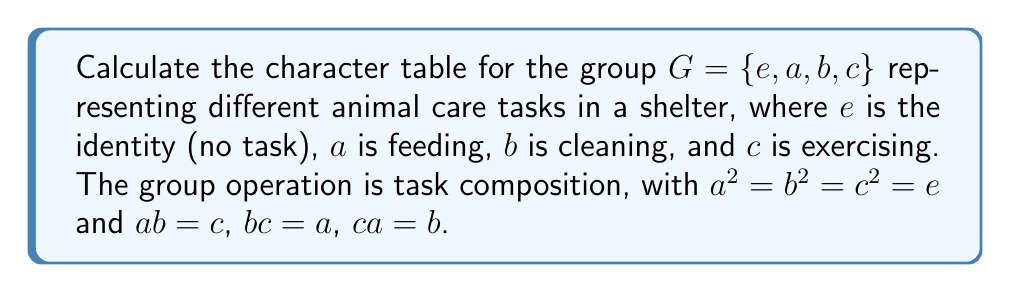Can you solve this math problem? 1) First, identify the conjugacy classes:
   - $\{e\}$ (identity)
   - $\{a, b, c\}$ (all other elements are conjugate to each other)

2) The number of irreducible representations equals the number of conjugacy classes, so there are two irreducible representations.

3) The sum of squares of dimensions of irreducible representations equals the order of the group:
   $d_1^2 + d_2^2 = 4$
   The only integer solution is $d_1 = 1$ and $d_2 = \sqrt{3}$

4) For the trivial representation $\chi_1$:
   $\chi_1(e) = 1$, $\chi_1(a) = \chi_1(b) = \chi_1(c) = 1$

5) For the second representation $\chi_2$:
   $\chi_2(e) = \sqrt{3}$
   To find $\chi_2(a)$, use the orthogonality of characters:
   $1 \cdot 1 + 3 \cdot \chi_2(a) = 0$
   $\chi_2(a) = -\frac{1}{3}$
   
   Due to conjugacy, $\chi_2(b) = \chi_2(c) = -\frac{1}{3}$

6) The character table is:

   $$
   \begin{array}{c|cc}
    G & \{e\} & \{a,b,c\} \\
    \hline
    \chi_1 & 1 & 1 \\
    \chi_2 & \sqrt{3} & -\frac{1}{3}
   \end{array}
   $$
Answer: $$
\begin{array}{c|cc}
G & \{e\} & \{a,b,c\} \\
\hline
\chi_1 & 1 & 1 \\
\chi_2 & \sqrt{3} & -\frac{1}{3}
\end{array}
$$ 